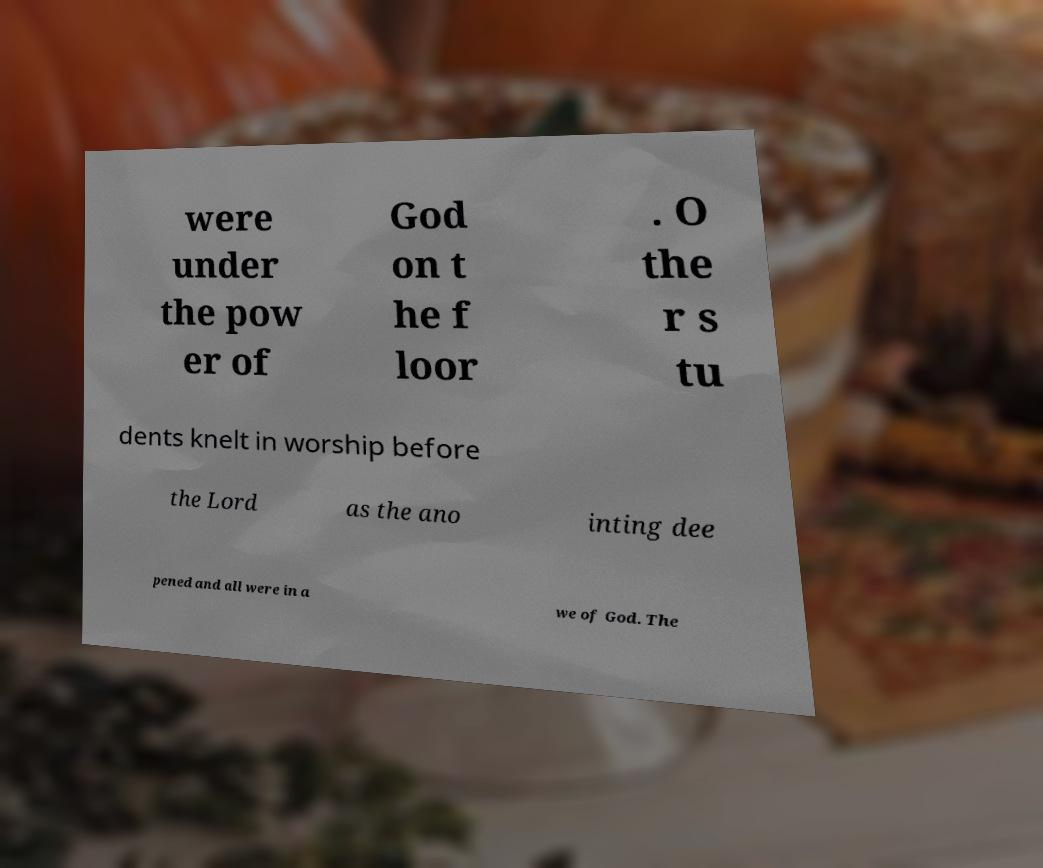Can you accurately transcribe the text from the provided image for me? were under the pow er of God on t he f loor . O the r s tu dents knelt in worship before the Lord as the ano inting dee pened and all were in a we of God. The 